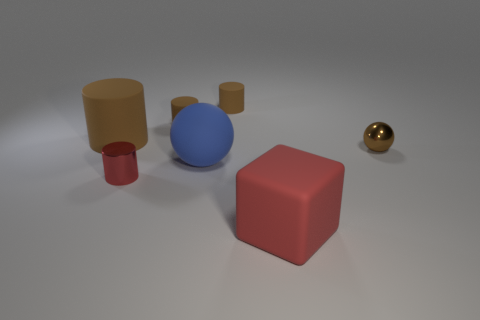Subtract all cyan spheres. How many brown cylinders are left? 3 Subtract all tiny cylinders. How many cylinders are left? 1 Add 3 large yellow rubber cubes. How many objects exist? 10 Subtract all brown spheres. How many spheres are left? 1 Subtract all cubes. How many objects are left? 6 Subtract 1 cylinders. How many cylinders are left? 3 Add 3 gray balls. How many gray balls exist? 3 Subtract 0 cyan blocks. How many objects are left? 7 Subtract all cyan blocks. Subtract all yellow cylinders. How many blocks are left? 1 Subtract all small brown matte things. Subtract all brown objects. How many objects are left? 1 